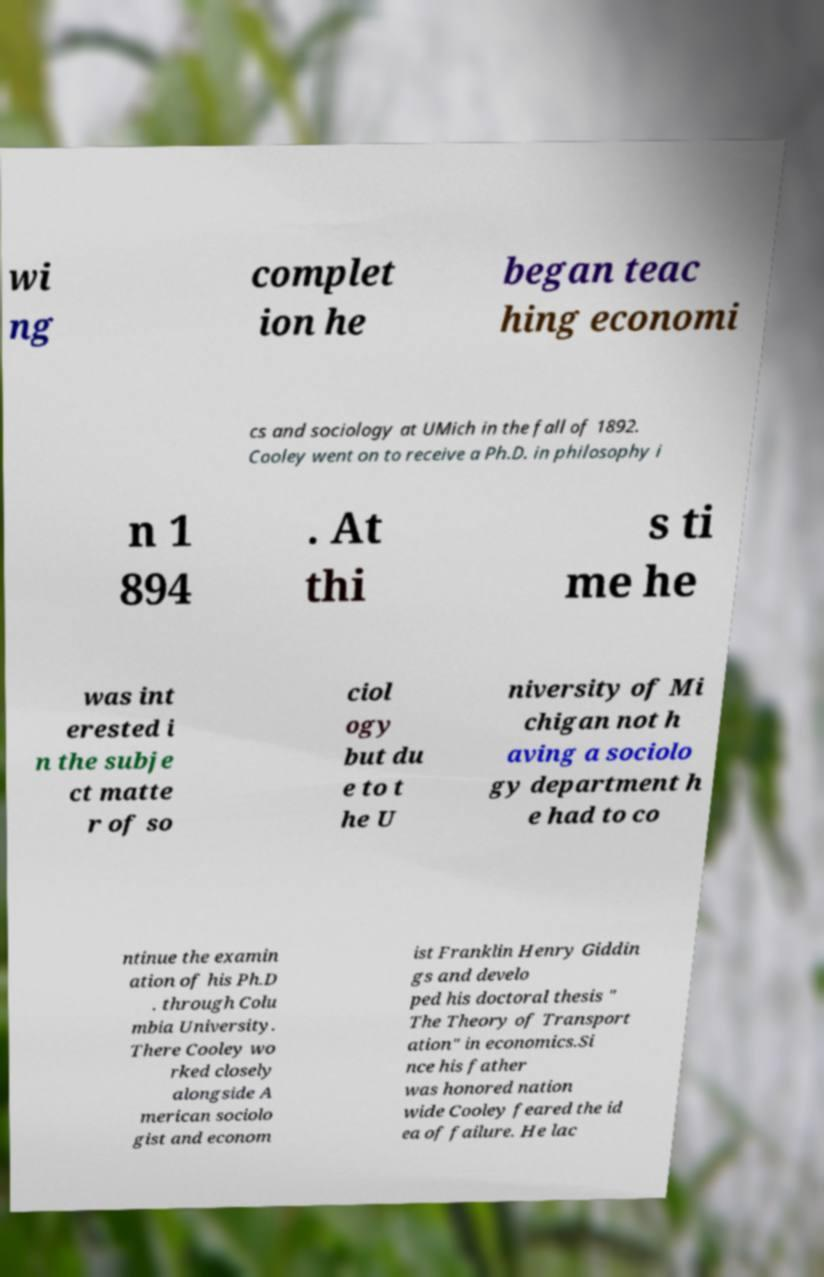There's text embedded in this image that I need extracted. Can you transcribe it verbatim? wi ng complet ion he began teac hing economi cs and sociology at UMich in the fall of 1892. Cooley went on to receive a Ph.D. in philosophy i n 1 894 . At thi s ti me he was int erested i n the subje ct matte r of so ciol ogy but du e to t he U niversity of Mi chigan not h aving a sociolo gy department h e had to co ntinue the examin ation of his Ph.D . through Colu mbia University. There Cooley wo rked closely alongside A merican sociolo gist and econom ist Franklin Henry Giddin gs and develo ped his doctoral thesis " The Theory of Transport ation" in economics.Si nce his father was honored nation wide Cooley feared the id ea of failure. He lac 